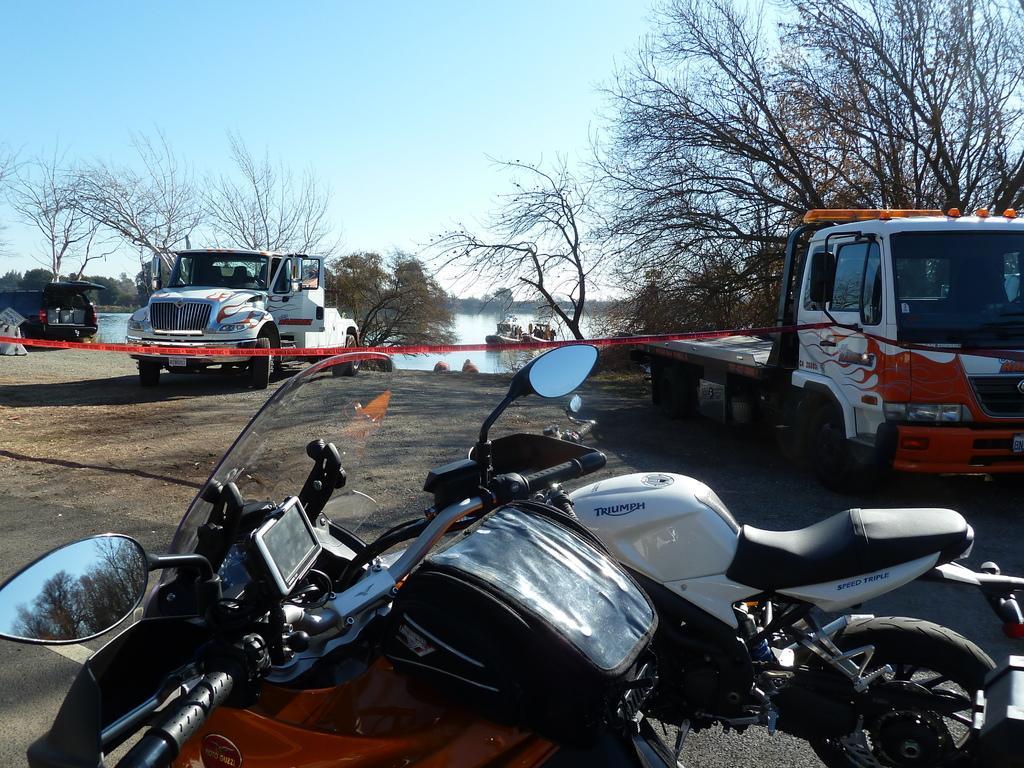Can you describe this image briefly? In the image there are motorcycles in the front and behind there are trucks followed by a pond with trees in front of it and above its sky. 